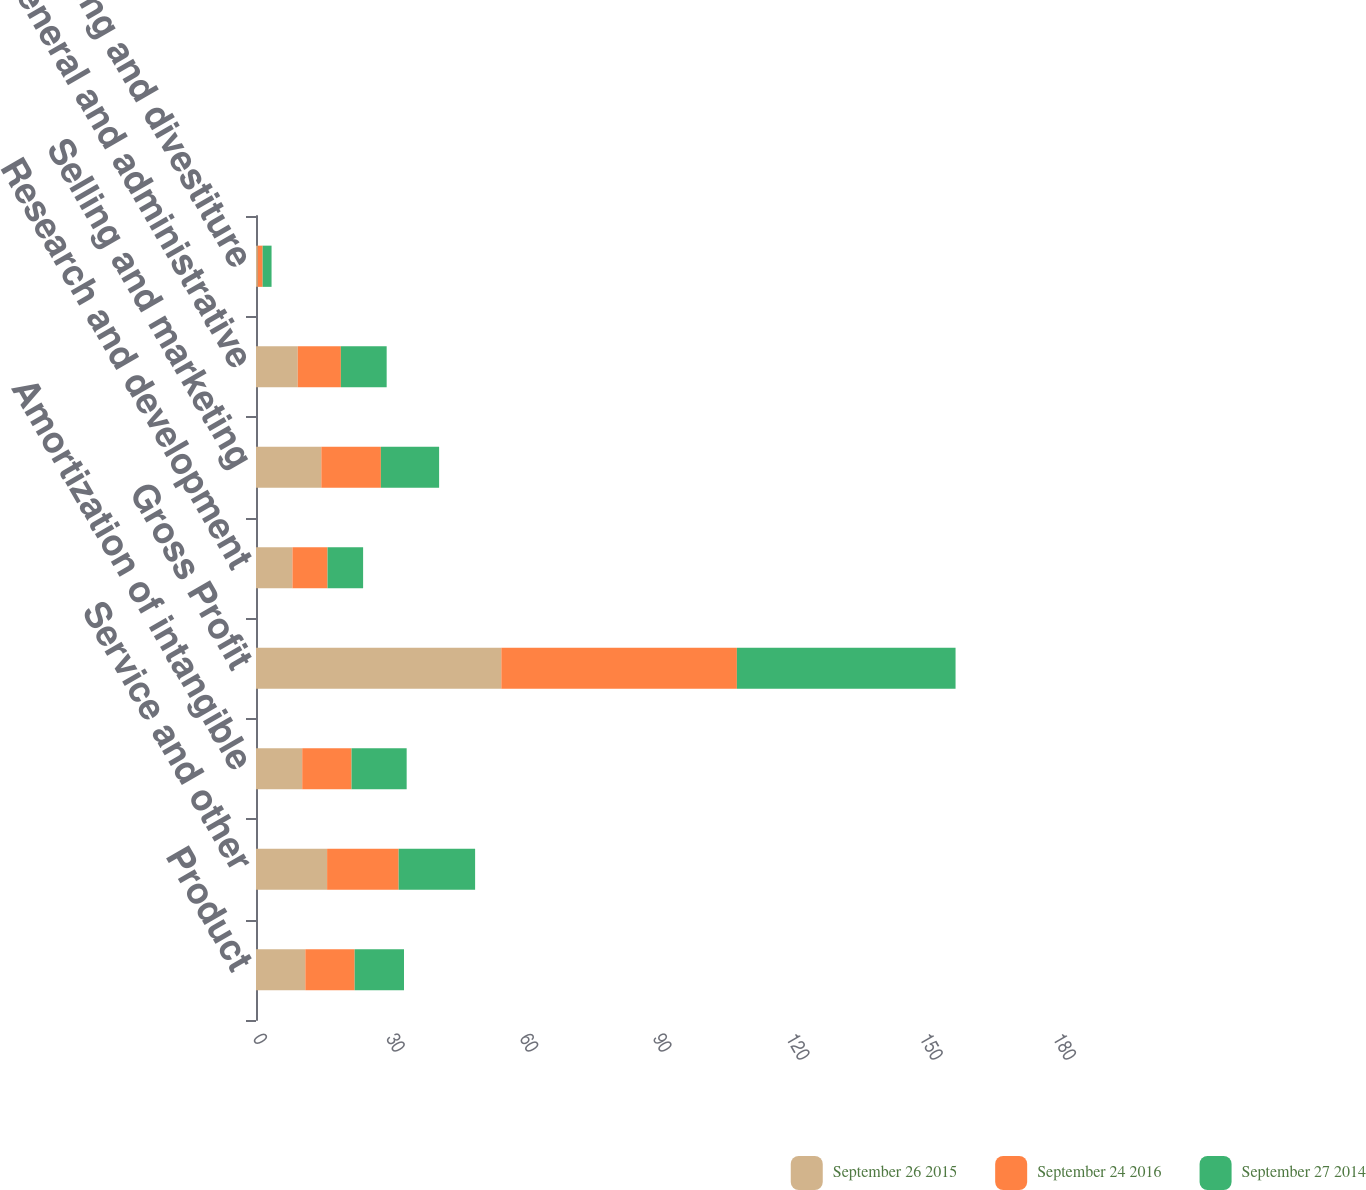Convert chart. <chart><loc_0><loc_0><loc_500><loc_500><stacked_bar_chart><ecel><fcel>Product<fcel>Service and other<fcel>Amortization of intangible<fcel>Gross Profit<fcel>Research and development<fcel>Selling and marketing<fcel>General and administrative<fcel>Restructuring and divestiture<nl><fcel>September 26 2015<fcel>11.1<fcel>16<fcel>10.4<fcel>55.2<fcel>8.2<fcel>14.7<fcel>9.4<fcel>0.4<nl><fcel>September 24 2016<fcel>11.1<fcel>16.1<fcel>11.1<fcel>53<fcel>7.9<fcel>13.4<fcel>9.7<fcel>1.1<nl><fcel>September 27 2014<fcel>11.1<fcel>17.2<fcel>12.4<fcel>49.2<fcel>8<fcel>13.1<fcel>10.3<fcel>2<nl></chart> 